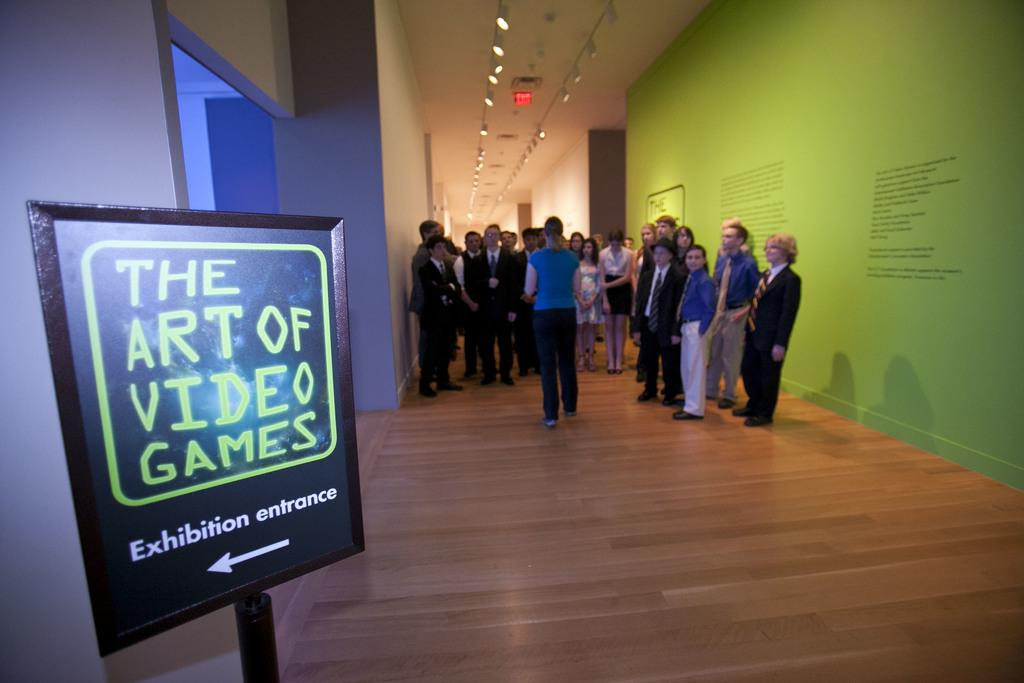<image>
Present a compact description of the photo's key features. A display sign posts to the entrance of The Art of Video Games exhibition. 